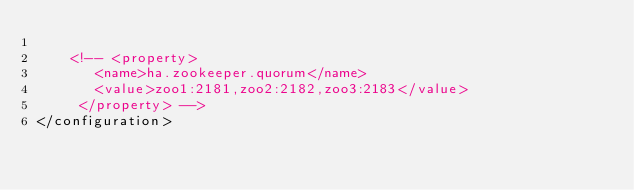<code> <loc_0><loc_0><loc_500><loc_500><_XML_>
    <!-- <property>
       <name>ha.zookeeper.quorum</name>
       <value>zoo1:2181,zoo2:2182,zoo3:2183</value>
     </property> -->
</configuration>
</code> 